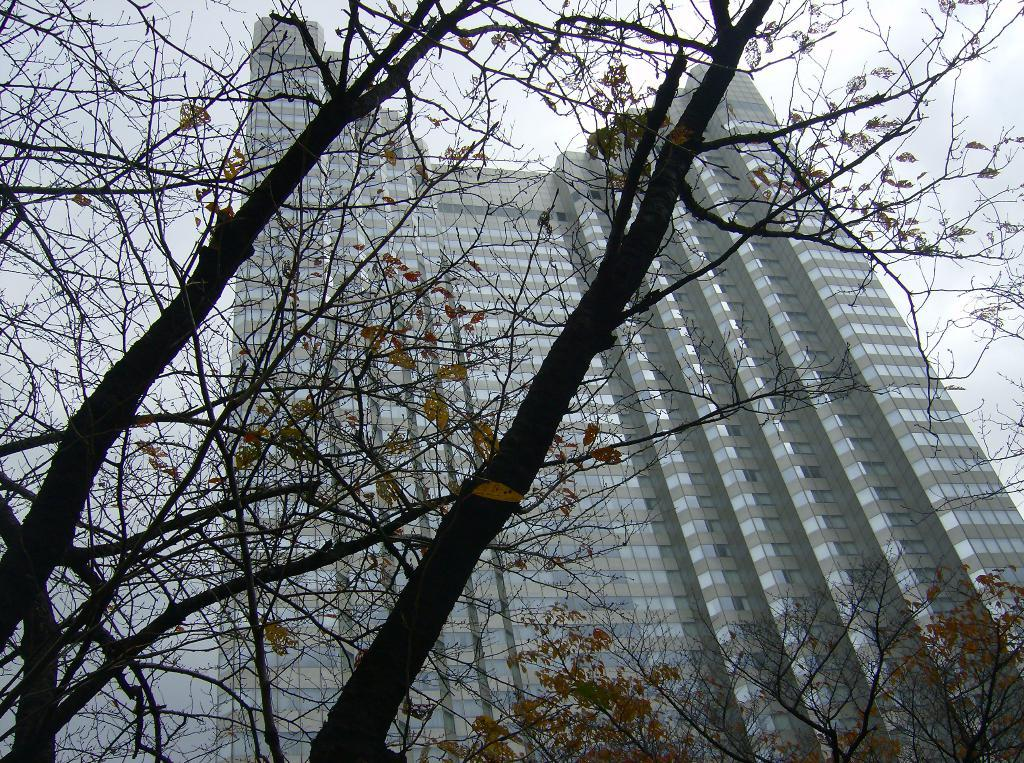What type of structure is present in the image? There is a building in the image. What other natural elements can be seen in the image? There are many trees in the image. What part of the environment is visible in the image? The sky is visible in the image. What type of mint is growing near the building in the image? There is no mint visible in the image; it only features a building, trees, and the sky. 